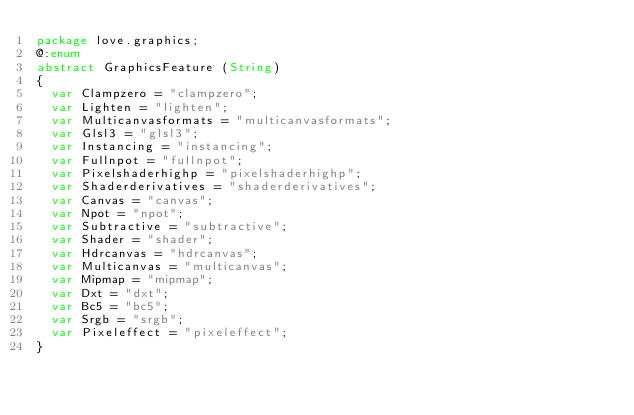<code> <loc_0><loc_0><loc_500><loc_500><_Haxe_>package love.graphics;
@:enum
abstract GraphicsFeature (String)
{
	var Clampzero = "clampzero";
	var Lighten = "lighten";
	var Multicanvasformats = "multicanvasformats";
	var Glsl3 = "glsl3";
	var Instancing = "instancing";
	var Fullnpot = "fullnpot";
	var Pixelshaderhighp = "pixelshaderhighp";
	var Shaderderivatives = "shaderderivatives";
	var Canvas = "canvas";
	var Npot = "npot";
	var Subtractive = "subtractive";
	var Shader = "shader";
	var Hdrcanvas = "hdrcanvas";
	var Multicanvas = "multicanvas";
	var Mipmap = "mipmap";
	var Dxt = "dxt";
	var Bc5 = "bc5";
	var Srgb = "srgb";
	var Pixeleffect = "pixeleffect";
}</code> 